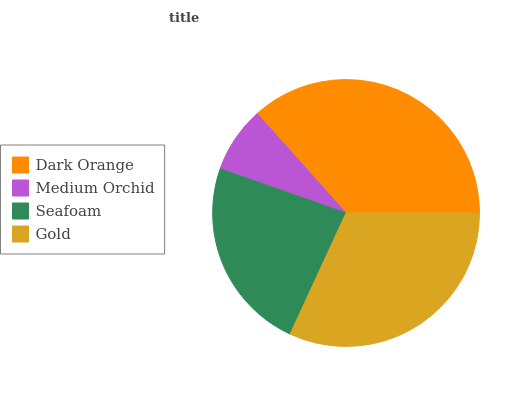Is Medium Orchid the minimum?
Answer yes or no. Yes. Is Dark Orange the maximum?
Answer yes or no. Yes. Is Seafoam the minimum?
Answer yes or no. No. Is Seafoam the maximum?
Answer yes or no. No. Is Seafoam greater than Medium Orchid?
Answer yes or no. Yes. Is Medium Orchid less than Seafoam?
Answer yes or no. Yes. Is Medium Orchid greater than Seafoam?
Answer yes or no. No. Is Seafoam less than Medium Orchid?
Answer yes or no. No. Is Gold the high median?
Answer yes or no. Yes. Is Seafoam the low median?
Answer yes or no. Yes. Is Seafoam the high median?
Answer yes or no. No. Is Medium Orchid the low median?
Answer yes or no. No. 